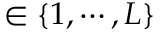<formula> <loc_0><loc_0><loc_500><loc_500>\in \{ 1 , \cdots , L \}</formula> 